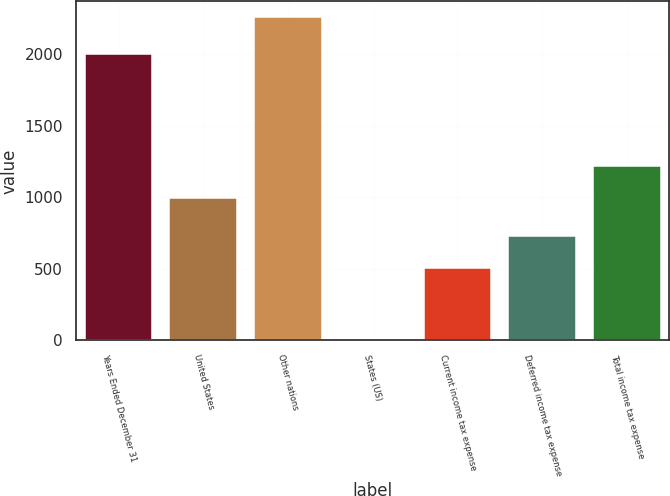<chart> <loc_0><loc_0><loc_500><loc_500><bar_chart><fcel>Years Ended December 31<fcel>United States<fcel>Other nations<fcel>States (US)<fcel>Current income tax expense<fcel>Deferred income tax expense<fcel>Total income tax expense<nl><fcel>2004<fcel>994<fcel>2258<fcel>6<fcel>506<fcel>731.2<fcel>1219.2<nl></chart> 